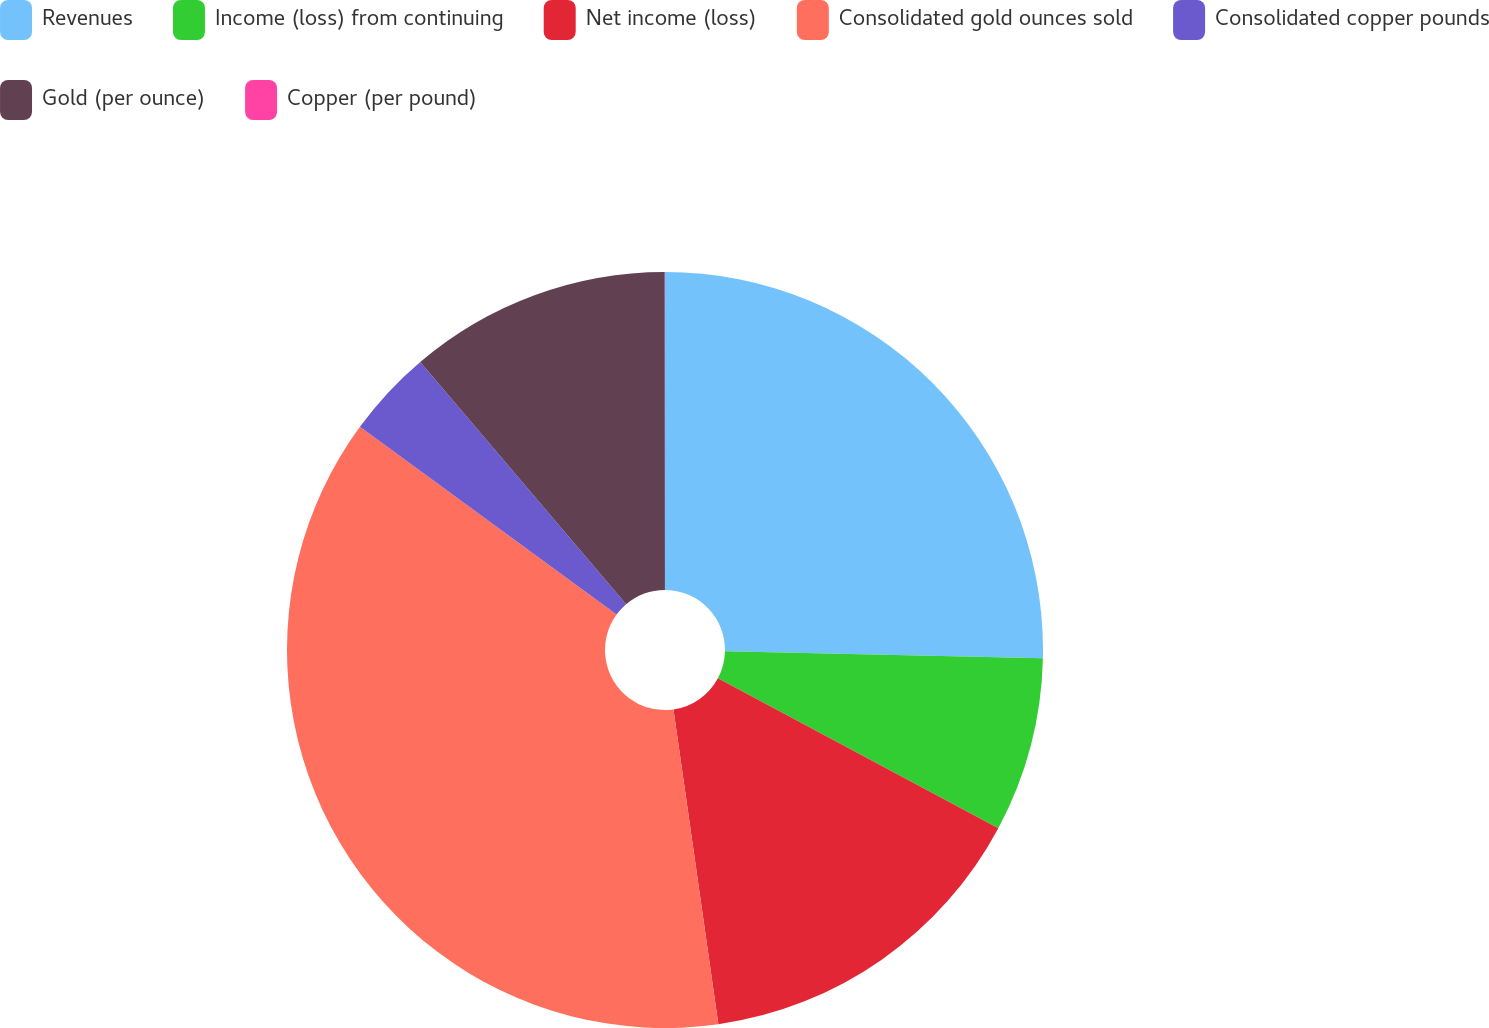<chart> <loc_0><loc_0><loc_500><loc_500><pie_chart><fcel>Revenues<fcel>Income (loss) from continuing<fcel>Net income (loss)<fcel>Consolidated gold ounces sold<fcel>Consolidated copper pounds<fcel>Gold (per ounce)<fcel>Copper (per pound)<nl><fcel>25.35%<fcel>7.47%<fcel>14.93%<fcel>37.31%<fcel>3.74%<fcel>11.2%<fcel>0.01%<nl></chart> 